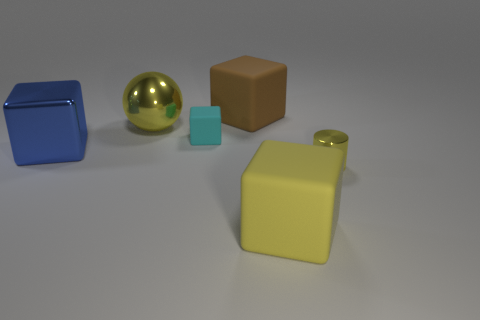Are there any purple metallic objects?
Your answer should be very brief. No. There is a object that is in front of the blue metallic cube and left of the small yellow object; what color is it?
Ensure brevity in your answer.  Yellow. Does the yellow object that is right of the yellow cube have the same size as the yellow object left of the large yellow matte cube?
Ensure brevity in your answer.  No. What number of other objects are the same size as the blue object?
Ensure brevity in your answer.  3. What number of tiny cyan matte cubes are in front of the big rubber block that is behind the large yellow ball?
Your response must be concise. 1. Are there fewer tiny yellow things to the left of the big yellow shiny ball than cyan matte things?
Your answer should be compact. Yes. What shape is the rubber object behind the yellow thing that is behind the tiny thing right of the small matte object?
Provide a succinct answer. Cube. Does the big brown object have the same shape as the blue object?
Provide a short and direct response. Yes. What number of other objects are the same shape as the small matte object?
Offer a terse response. 3. There is a metal thing that is the same size as the cyan cube; what color is it?
Give a very brief answer. Yellow. 